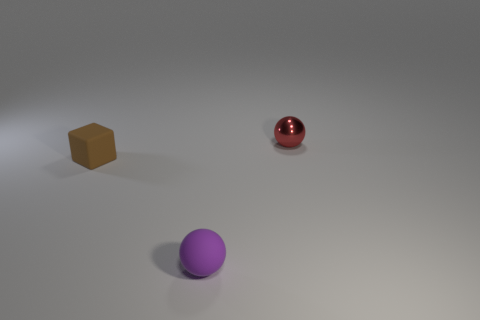What could be the possible material of the red sphere? Given the shiny, reflective surface of the red sphere, it could be made of a polished material such as plastic, glass, or a glossy-painted metal. 